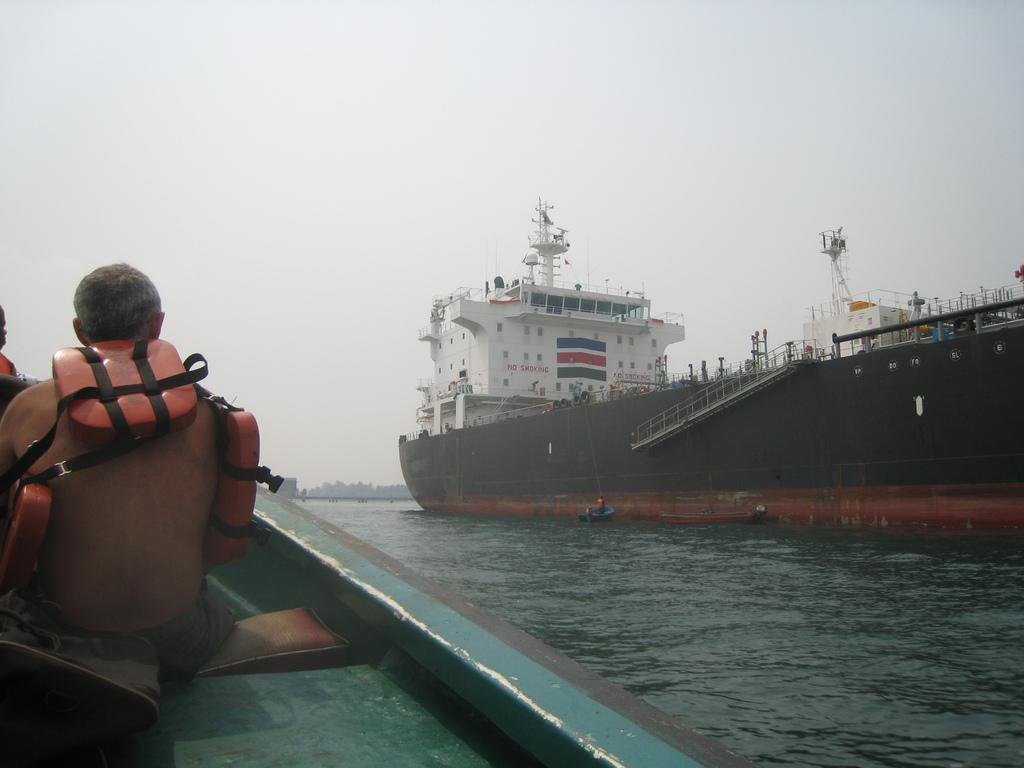What is the main subject of the image? The main subject of the image is a big ship. Where is the ship located in the image? The ship is on the water. Can you describe any other elements in the image? There is a man sitting on the left side of the image. What type of book is the man reading in the image? There is no book present in the image; the man is simply sitting on the left side. 